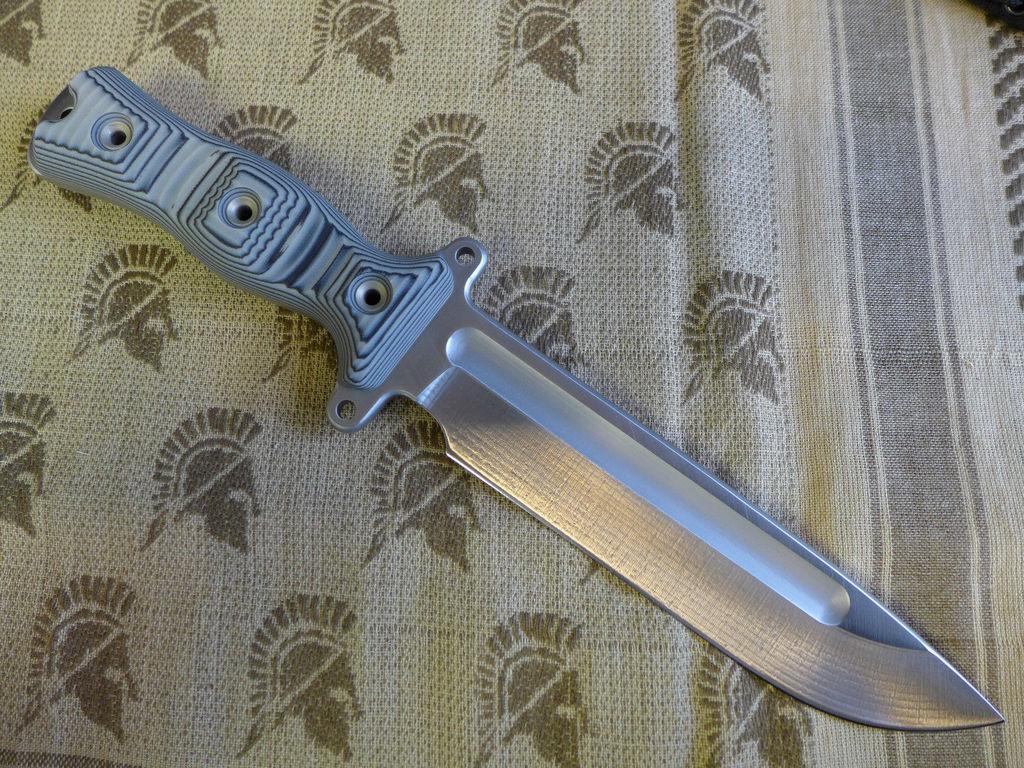Can you describe this image briefly? In this picture there is a knife in the center of the image. 